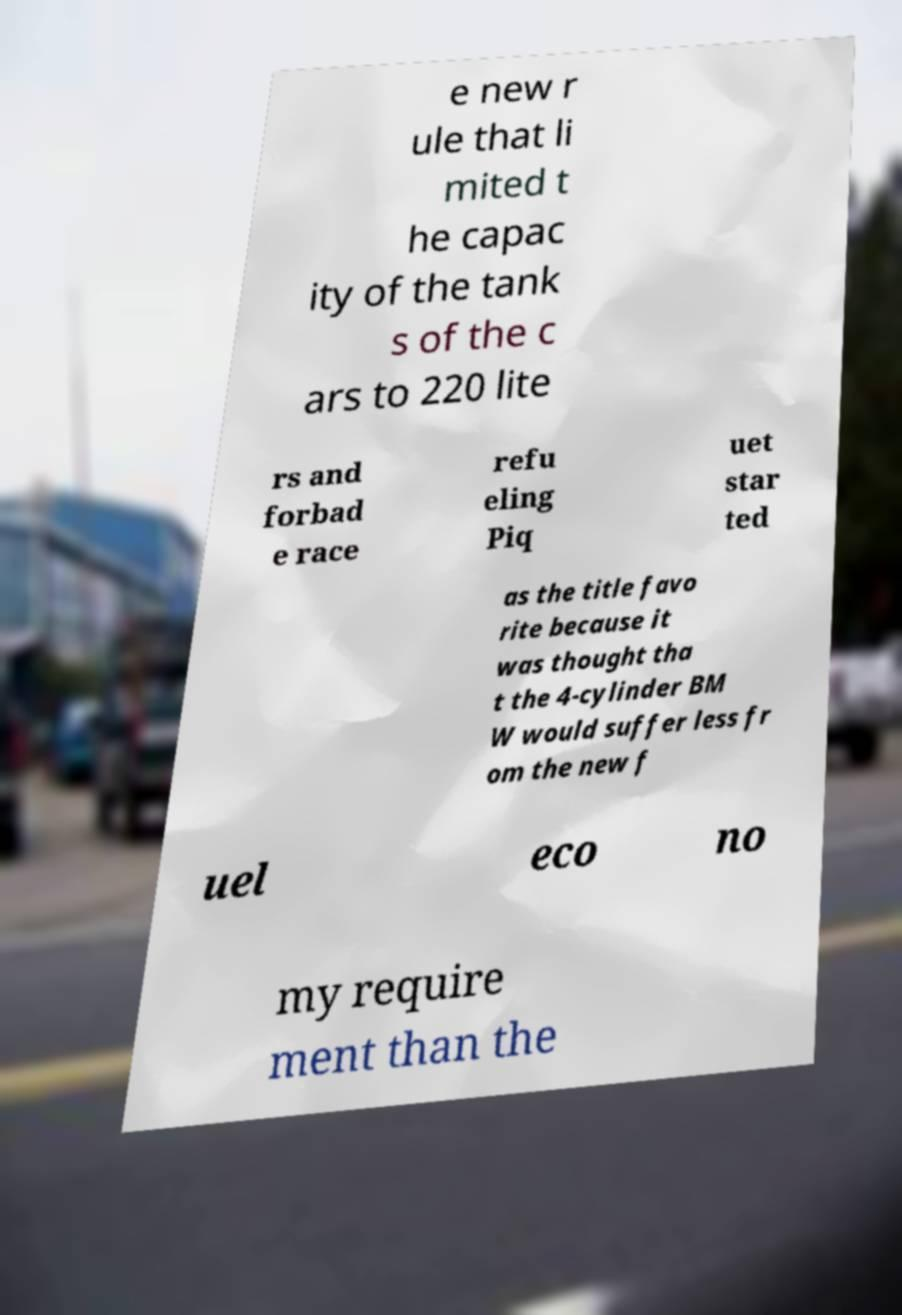What messages or text are displayed in this image? I need them in a readable, typed format. e new r ule that li mited t he capac ity of the tank s of the c ars to 220 lite rs and forbad e race refu eling Piq uet star ted as the title favo rite because it was thought tha t the 4-cylinder BM W would suffer less fr om the new f uel eco no my require ment than the 